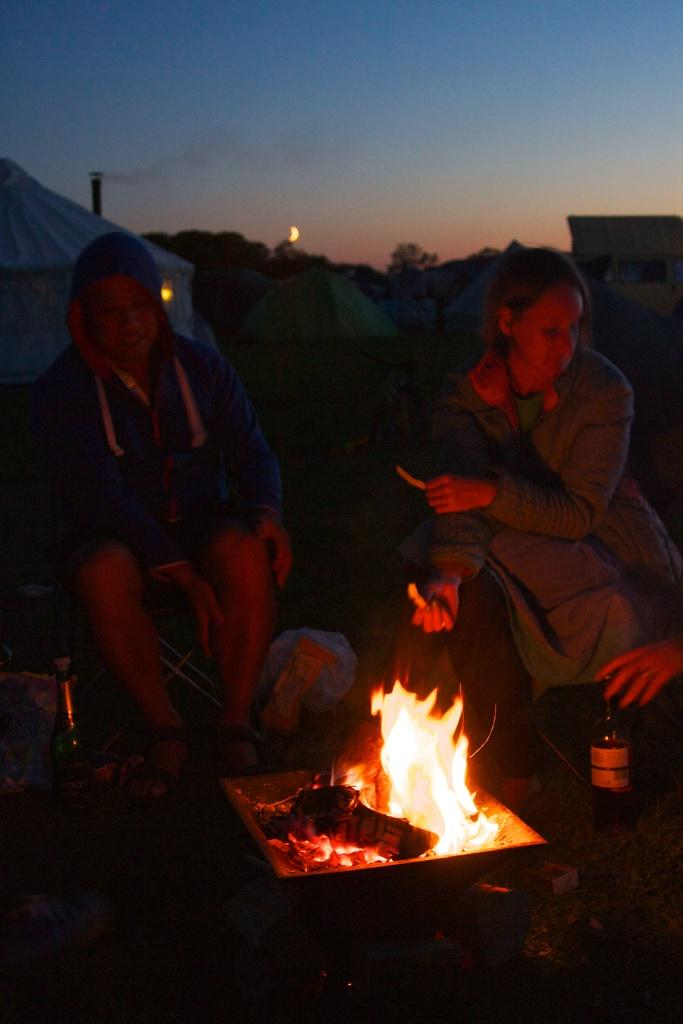Who or what can be seen in the image? There are people in the image. What objects are in front of the people? There are bottles and fire in front of the people. What structures are visible in the background of the image? There are tents and trees in the background of the image. How does the desk contribute to the scene in the image? There is no desk present in the image. What role does the zinc play in the image? There is no zinc present in the image. 